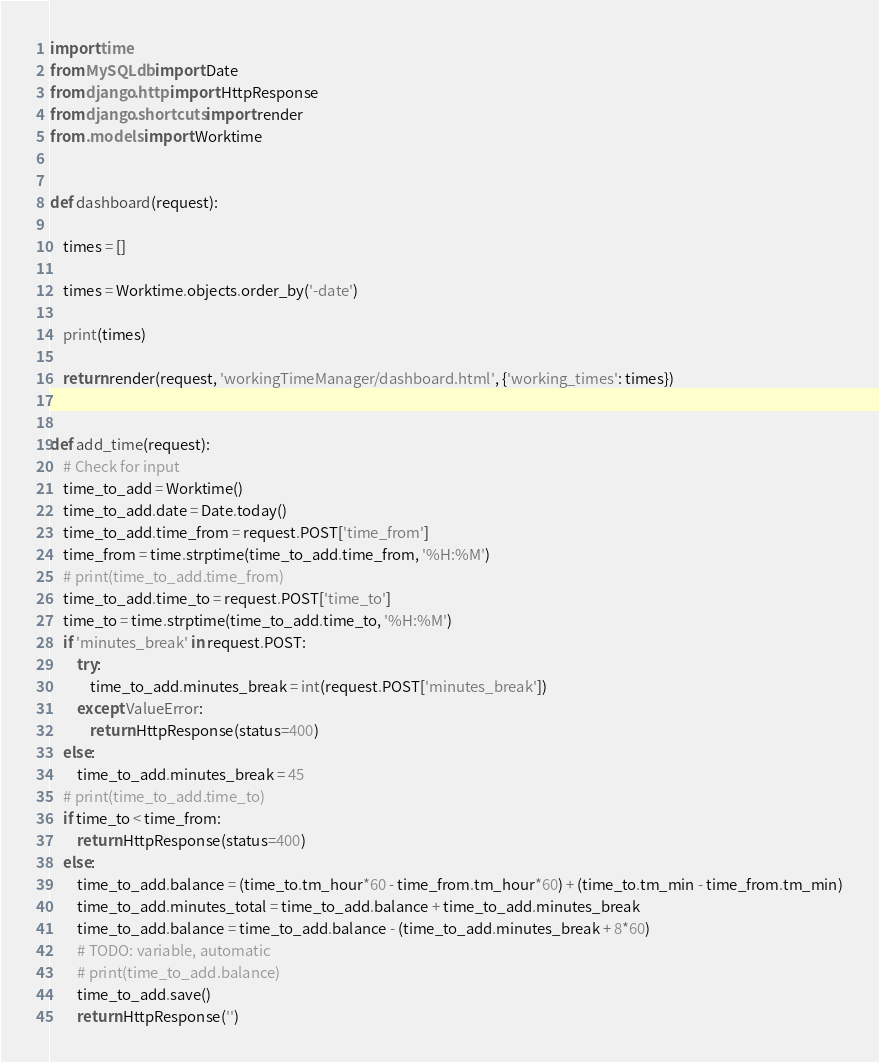Convert code to text. <code><loc_0><loc_0><loc_500><loc_500><_Python_>import time
from MySQLdb import Date
from django.http import HttpResponse
from django.shortcuts import render
from .models import Worktime


def dashboard(request):

    times = []

    times = Worktime.objects.order_by('-date')

    print(times)

    return render(request, 'workingTimeManager/dashboard.html', {'working_times': times})


def add_time(request):
    # Check for input
    time_to_add = Worktime()
    time_to_add.date = Date.today()
    time_to_add.time_from = request.POST['time_from']
    time_from = time.strptime(time_to_add.time_from, '%H:%M')
    # print(time_to_add.time_from)
    time_to_add.time_to = request.POST['time_to']
    time_to = time.strptime(time_to_add.time_to, '%H:%M')
    if 'minutes_break' in request.POST:
        try:
            time_to_add.minutes_break = int(request.POST['minutes_break'])
        except ValueError:
            return HttpResponse(status=400)
    else:
        time_to_add.minutes_break = 45
    # print(time_to_add.time_to)
    if time_to < time_from:
        return HttpResponse(status=400)
    else:
        time_to_add.balance = (time_to.tm_hour*60 - time_from.tm_hour*60) + (time_to.tm_min - time_from.tm_min)
        time_to_add.minutes_total = time_to_add.balance + time_to_add.minutes_break
        time_to_add.balance = time_to_add.balance - (time_to_add.minutes_break + 8*60)
        # TODO: variable, automatic
        # print(time_to_add.balance)
        time_to_add.save()
        return HttpResponse('')
</code> 